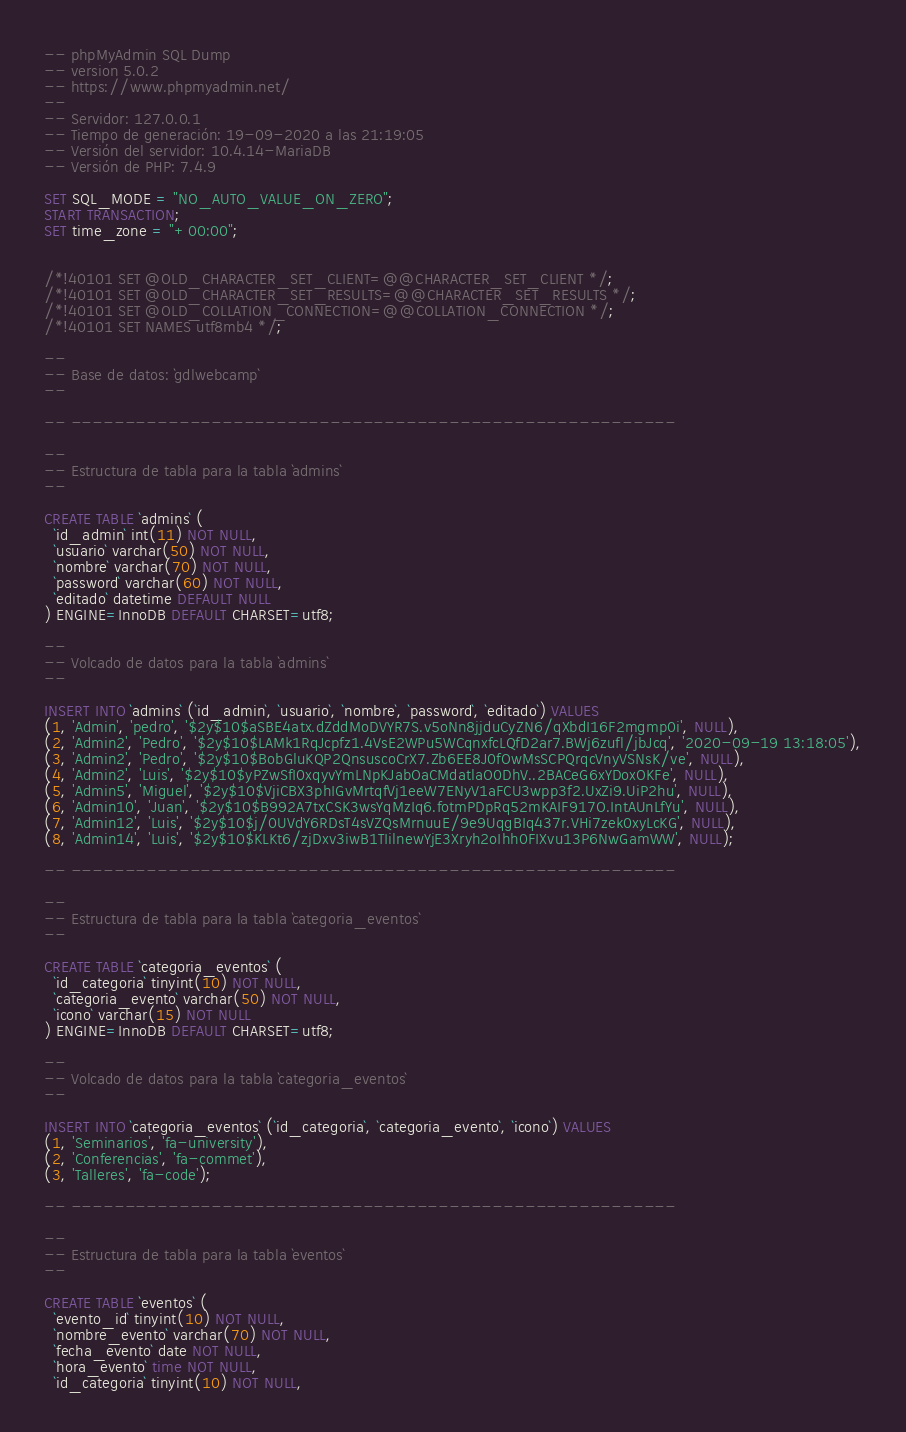Convert code to text. <code><loc_0><loc_0><loc_500><loc_500><_SQL_>-- phpMyAdmin SQL Dump
-- version 5.0.2
-- https://www.phpmyadmin.net/
--
-- Servidor: 127.0.0.1
-- Tiempo de generación: 19-09-2020 a las 21:19:05
-- Versión del servidor: 10.4.14-MariaDB
-- Versión de PHP: 7.4.9

SET SQL_MODE = "NO_AUTO_VALUE_ON_ZERO";
START TRANSACTION;
SET time_zone = "+00:00";


/*!40101 SET @OLD_CHARACTER_SET_CLIENT=@@CHARACTER_SET_CLIENT */;
/*!40101 SET @OLD_CHARACTER_SET_RESULTS=@@CHARACTER_SET_RESULTS */;
/*!40101 SET @OLD_COLLATION_CONNECTION=@@COLLATION_CONNECTION */;
/*!40101 SET NAMES utf8mb4 */;

--
-- Base de datos: `gdlwebcamp`
--

-- --------------------------------------------------------

--
-- Estructura de tabla para la tabla `admins`
--

CREATE TABLE `admins` (
  `id_admin` int(11) NOT NULL,
  `usuario` varchar(50) NOT NULL,
  `nombre` varchar(70) NOT NULL,
  `password` varchar(60) NOT NULL,
  `editado` datetime DEFAULT NULL
) ENGINE=InnoDB DEFAULT CHARSET=utf8;

--
-- Volcado de datos para la tabla `admins`
--

INSERT INTO `admins` (`id_admin`, `usuario`, `nombre`, `password`, `editado`) VALUES
(1, 'Admin', 'pedro', '$2y$10$aSBE4atx.dZddMoDVYR7S.v5oNn8jjduCyZN6/qXbdI16F2mgmp0i', NULL),
(2, 'Admin2', 'Pedro', '$2y$10$LAMk1RqJcpfz1.4VsE2WPu5WCqnxfcLQfD2ar7.BWj6zufl/jbJcq', '2020-09-19 13:18:05'),
(3, 'Admin2', 'Pedro', '$2y$10$BobGluKQP2QnsuscoCrX7.Zb6EE8J0fOwMsSCPQrqcVnyVSNsK/ve', NULL),
(4, 'Admin2', 'Luis', '$2y$10$yPZwSfI0xqyvYmLNpKJabOaCMdatlaO0DhV..2BACeG6xYDoxOKFe', NULL),
(5, 'Admin5', 'Miguel', '$2y$10$VjiCBX3phIGvMrtqfVj1eeW7ENyV1aFCU3wpp3f2.UxZi9.UiP2hu', NULL),
(6, 'Admin10', 'Juan', '$2y$10$B992A7txCSK3wsYqMzIq6.fotmPDpRq52mKAIF917O.IntAUnLfYu', NULL),
(7, 'Admin12', 'Luis', '$2y$10$j/0UVdY6RDsT4sVZQsMrnuuE/9e9UqgBIq437r.VHi7zek0xyLcKG', NULL),
(8, 'Admin14', 'Luis', '$2y$10$KLKt6/zjDxv3iwB1TIilnewYjE3Xryh2oIhh0FIXvu13P6NwGamWW', NULL);

-- --------------------------------------------------------

--
-- Estructura de tabla para la tabla `categoria_eventos`
--

CREATE TABLE `categoria_eventos` (
  `id_categoria` tinyint(10) NOT NULL,
  `categoria_evento` varchar(50) NOT NULL,
  `icono` varchar(15) NOT NULL
) ENGINE=InnoDB DEFAULT CHARSET=utf8;

--
-- Volcado de datos para la tabla `categoria_eventos`
--

INSERT INTO `categoria_eventos` (`id_categoria`, `categoria_evento`, `icono`) VALUES
(1, 'Seminarios', 'fa-university'),
(2, 'Conferencias', 'fa-commet'),
(3, 'Talleres', 'fa-code');

-- --------------------------------------------------------

--
-- Estructura de tabla para la tabla `eventos`
--

CREATE TABLE `eventos` (
  `evento_id` tinyint(10) NOT NULL,
  `nombre_evento` varchar(70) NOT NULL,
  `fecha_evento` date NOT NULL,
  `hora_evento` time NOT NULL,
  `id_categoria` tinyint(10) NOT NULL,</code> 